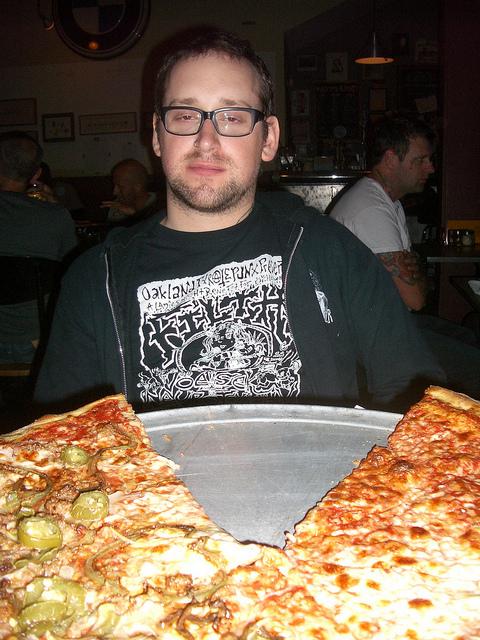Does this gentlemen look like he has had too much to drink?
Keep it brief. Yes. How many pieces are missing?
Give a very brief answer. 1. Has any of the pizza shown been eaten?
Quick response, please. Yes. 